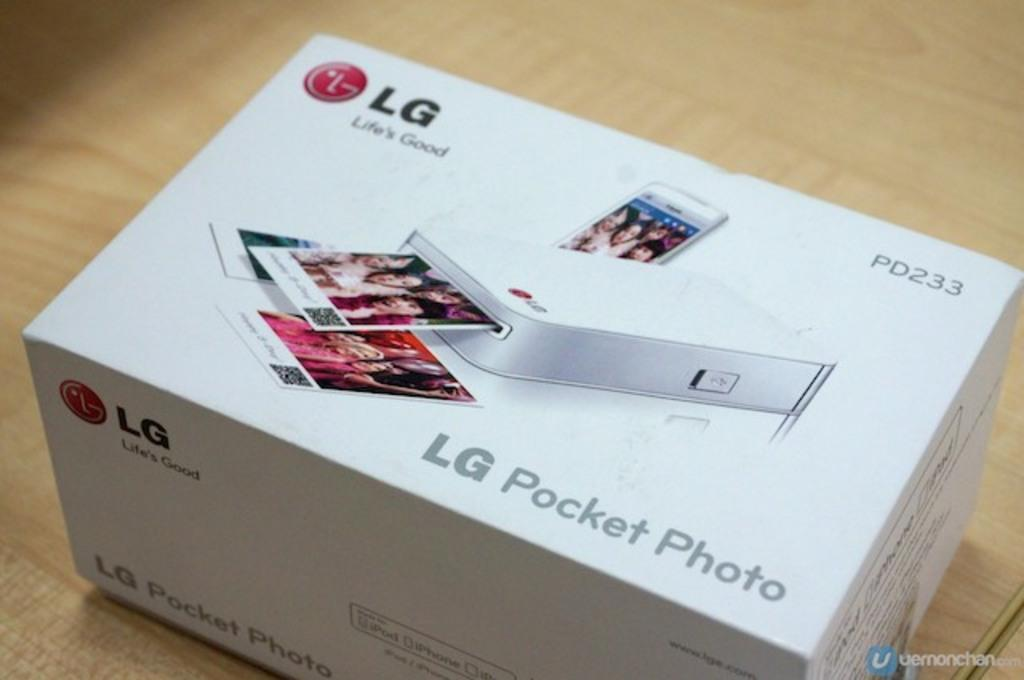<image>
Share a concise interpretation of the image provided. An LG photo printer box sits on a wooden table 